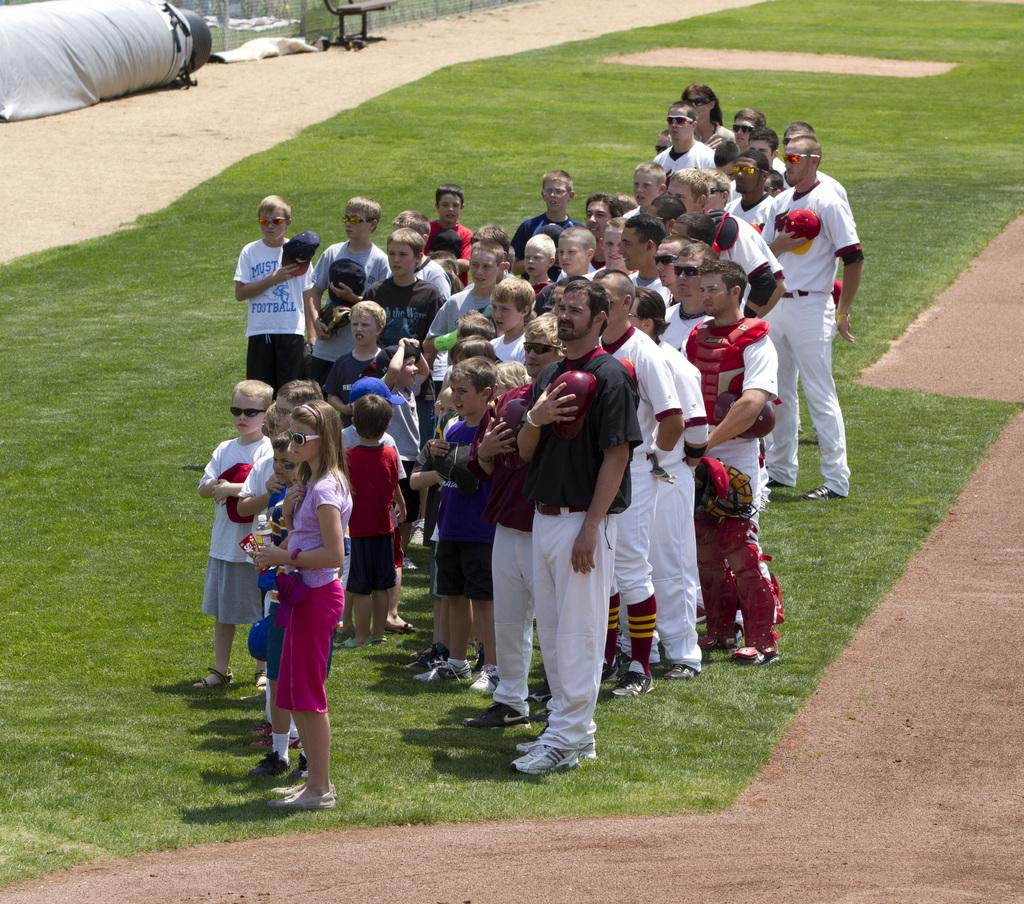How many people are in the image? There is a group of people in the image. Where are the people standing? The people are standing on the grass. What can be seen in the background of the image? There is a fence and a chair in the background of the image. What type of ground is visible at the bottom of the image? Grass and mud are present at the bottom of the image. What type of pencil is being used by the representative in the image? There is no representative or pencil present in the image. 